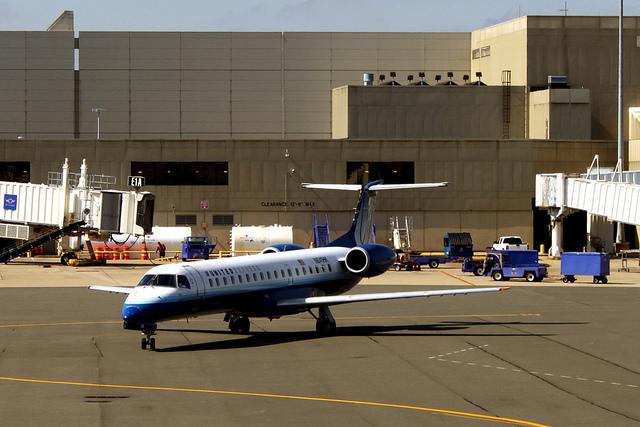Is this likely a commuter plane?
Quick response, please. Yes. What color is the bottom of the plane?
Write a very short answer. Blue. Are there people in the plane?
Write a very short answer. Yes. 